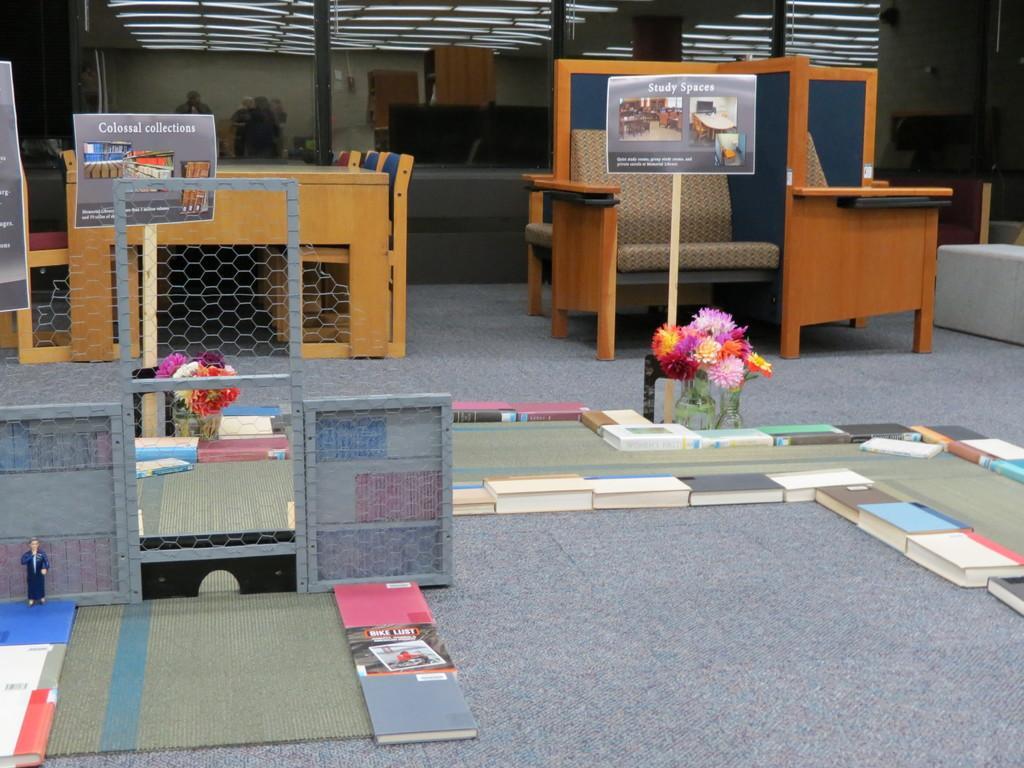Please provide a concise description of this image. In this image in the center there are some books flowers, at the bottom also there are some books and a toy and some boards and net. In the background there are some tables, chairs and some boards and also there are some people who are standing and we could see some couches, doors and wall and also some boards. On the top there is ceiling. 